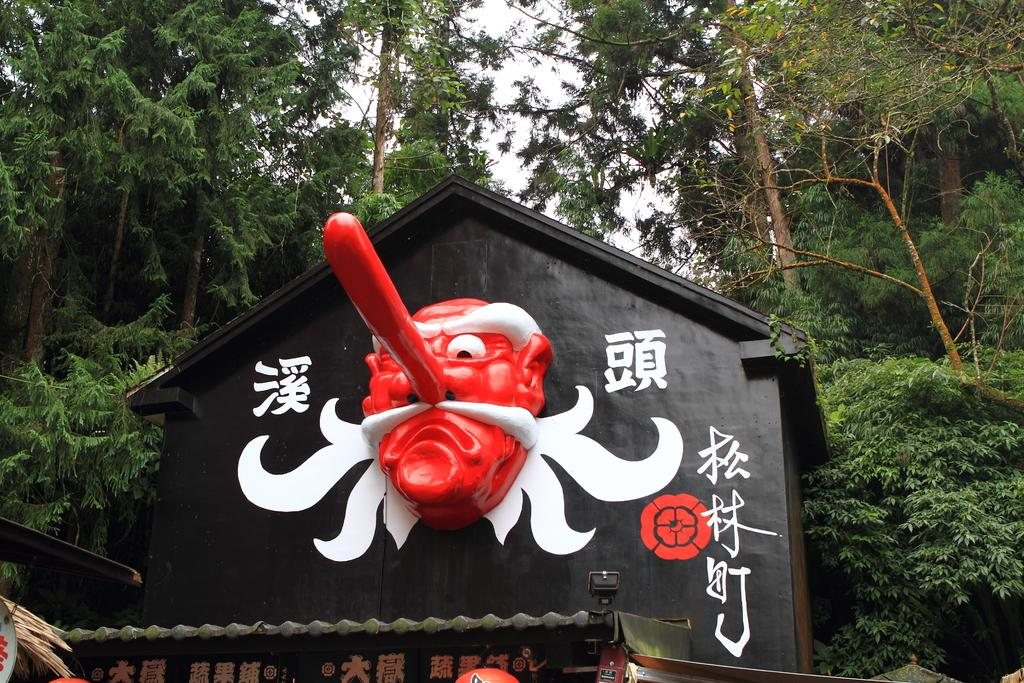What type of house is shown in the image? There is a wooden black color house in the image. Are there any words or letters on the house? Yes, there is text written on the house. What can be seen in the background of the image? There are many trees visible in the background of the image. Can you see a bear climbing one of the trees in the background? No, there is no bear visible in the image. 